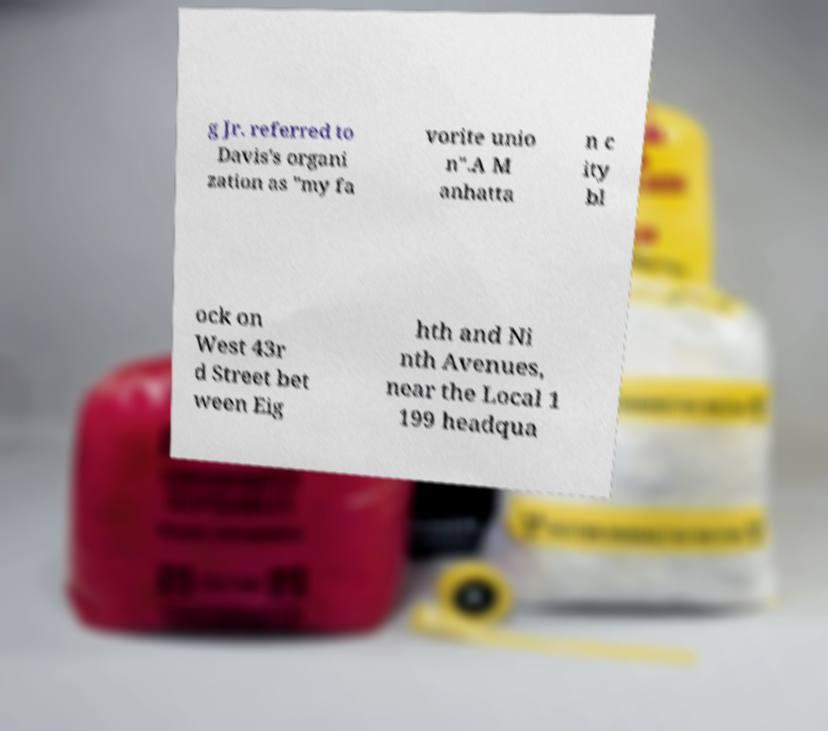Can you read and provide the text displayed in the image?This photo seems to have some interesting text. Can you extract and type it out for me? g Jr. referred to Davis's organi zation as "my fa vorite unio n".A M anhatta n c ity bl ock on West 43r d Street bet ween Eig hth and Ni nth Avenues, near the Local 1 199 headqua 